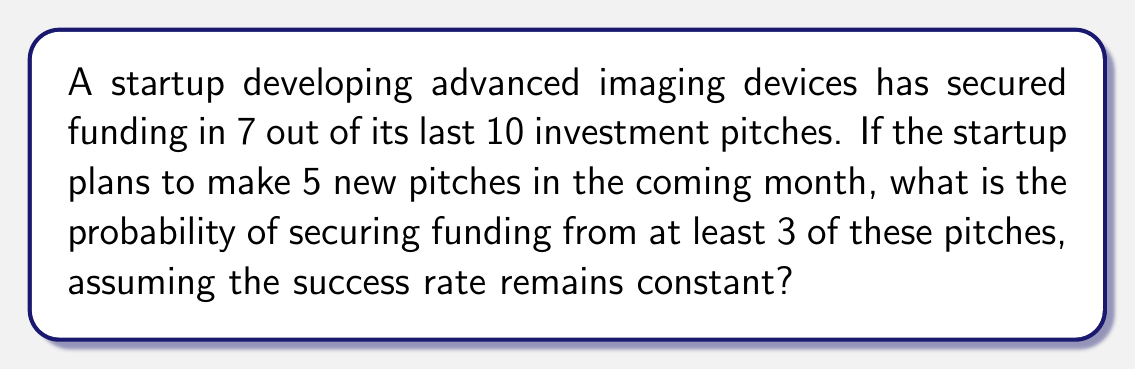Give your solution to this math problem. Let's approach this step-by-step:

1) First, we need to identify the probability of success for a single pitch:
   $p = \frac{7}{10} = 0.7$

2) The probability of failure for a single pitch is:
   $q = 1 - p = 1 - 0.7 = 0.3$

3) We want the probability of at least 3 successes out of 5 pitches. This can be calculated using the binomial probability formula:

   $P(X \geq 3) = P(X = 3) + P(X = 4) + P(X = 5)$

4) The binomial probability formula is:

   $P(X = k) = \binom{n}{k} p^k q^{n-k}$

   Where $n$ is the number of trials (5 in this case), $k$ is the number of successes, $p$ is the probability of success, and $q$ is the probability of failure.

5) Let's calculate each probability:

   $P(X = 3) = \binom{5}{3} (0.7)^3 (0.3)^2 = 10 \cdot 0.343 \cdot 0.09 = 0.3087$

   $P(X = 4) = \binom{5}{4} (0.7)^4 (0.3)^1 = 5 \cdot 0.2401 \cdot 0.3 = 0.3602$

   $P(X = 5) = \binom{5}{5} (0.7)^5 (0.3)^0 = 1 \cdot 0.16807 \cdot 1 = 0.16807$

6) Now, we sum these probabilities:

   $P(X \geq 3) = 0.3087 + 0.3602 + 0.16807 = 0.83697$

Therefore, the probability of securing funding from at least 3 out of 5 pitches is approximately 0.83697 or 83.697%.
Answer: $0.83697$ or $83.697\%$ 